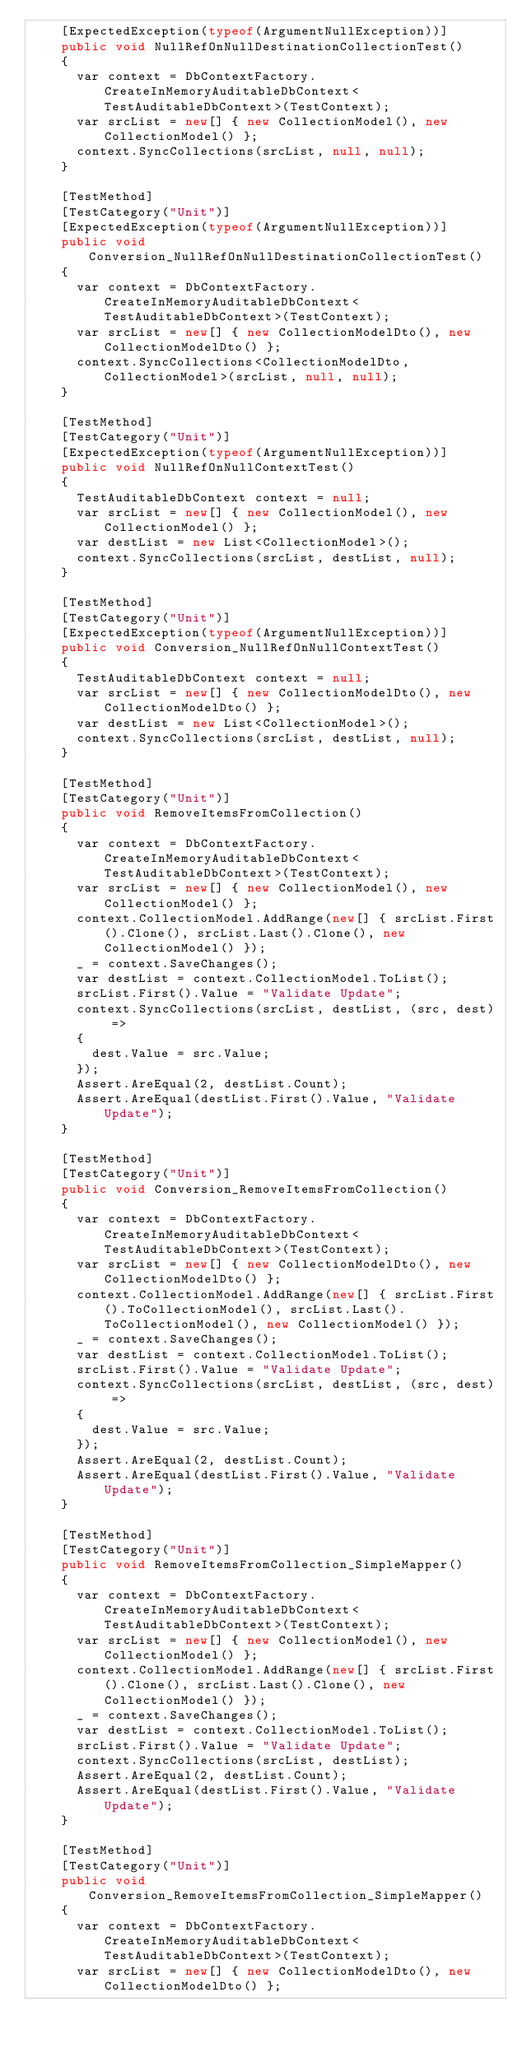<code> <loc_0><loc_0><loc_500><loc_500><_C#_>    [ExpectedException(typeof(ArgumentNullException))]
    public void NullRefOnNullDestinationCollectionTest()
    {
      var context = DbContextFactory.CreateInMemoryAuditableDbContext<TestAuditableDbContext>(TestContext);
      var srcList = new[] { new CollectionModel(), new CollectionModel() };
      context.SyncCollections(srcList, null, null);
    }

    [TestMethod]
    [TestCategory("Unit")]
    [ExpectedException(typeof(ArgumentNullException))]
    public void Conversion_NullRefOnNullDestinationCollectionTest()
    {
      var context = DbContextFactory.CreateInMemoryAuditableDbContext<TestAuditableDbContext>(TestContext);
      var srcList = new[] { new CollectionModelDto(), new CollectionModelDto() };
      context.SyncCollections<CollectionModelDto, CollectionModel>(srcList, null, null);
    }

    [TestMethod]
    [TestCategory("Unit")]
    [ExpectedException(typeof(ArgumentNullException))]
    public void NullRefOnNullContextTest()
    {
      TestAuditableDbContext context = null;
      var srcList = new[] { new CollectionModel(), new CollectionModel() };
      var destList = new List<CollectionModel>();
      context.SyncCollections(srcList, destList, null);
    }

    [TestMethod]
    [TestCategory("Unit")]
    [ExpectedException(typeof(ArgumentNullException))]
    public void Conversion_NullRefOnNullContextTest()
    {
      TestAuditableDbContext context = null;
      var srcList = new[] { new CollectionModelDto(), new CollectionModelDto() };
      var destList = new List<CollectionModel>();
      context.SyncCollections(srcList, destList, null);
    }

    [TestMethod]
    [TestCategory("Unit")]
    public void RemoveItemsFromCollection()
    {
      var context = DbContextFactory.CreateInMemoryAuditableDbContext<TestAuditableDbContext>(TestContext);
      var srcList = new[] { new CollectionModel(), new CollectionModel() };
      context.CollectionModel.AddRange(new[] { srcList.First().Clone(), srcList.Last().Clone(), new CollectionModel() });
      _ = context.SaveChanges();
      var destList = context.CollectionModel.ToList();
      srcList.First().Value = "Validate Update";
      context.SyncCollections(srcList, destList, (src, dest) =>
      {
        dest.Value = src.Value;
      });
      Assert.AreEqual(2, destList.Count);
      Assert.AreEqual(destList.First().Value, "Validate Update");
    }

    [TestMethod]
    [TestCategory("Unit")]
    public void Conversion_RemoveItemsFromCollection()
    {
      var context = DbContextFactory.CreateInMemoryAuditableDbContext<TestAuditableDbContext>(TestContext);
      var srcList = new[] { new CollectionModelDto(), new CollectionModelDto() };
      context.CollectionModel.AddRange(new[] { srcList.First().ToCollectionModel(), srcList.Last().ToCollectionModel(), new CollectionModel() });
      _ = context.SaveChanges();
      var destList = context.CollectionModel.ToList();
      srcList.First().Value = "Validate Update";
      context.SyncCollections(srcList, destList, (src, dest) =>
      {
        dest.Value = src.Value;
      });
      Assert.AreEqual(2, destList.Count);
      Assert.AreEqual(destList.First().Value, "Validate Update");
    }

    [TestMethod]
    [TestCategory("Unit")]
    public void RemoveItemsFromCollection_SimpleMapper()
    {
      var context = DbContextFactory.CreateInMemoryAuditableDbContext<TestAuditableDbContext>(TestContext);
      var srcList = new[] { new CollectionModel(), new CollectionModel() };
      context.CollectionModel.AddRange(new[] { srcList.First().Clone(), srcList.Last().Clone(), new CollectionModel() });
      _ = context.SaveChanges();
      var destList = context.CollectionModel.ToList();
      srcList.First().Value = "Validate Update";
      context.SyncCollections(srcList, destList);
      Assert.AreEqual(2, destList.Count);
      Assert.AreEqual(destList.First().Value, "Validate Update");
    }

    [TestMethod]
    [TestCategory("Unit")]
    public void Conversion_RemoveItemsFromCollection_SimpleMapper()
    {
      var context = DbContextFactory.CreateInMemoryAuditableDbContext<TestAuditableDbContext>(TestContext);
      var srcList = new[] { new CollectionModelDto(), new CollectionModelDto() };</code> 